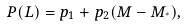<formula> <loc_0><loc_0><loc_500><loc_500>P ( L ) = p _ { 1 } + p _ { 2 } ( M - M _ { ^ { * } } ) ,</formula> 